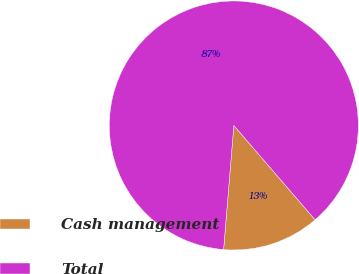Convert chart to OTSL. <chart><loc_0><loc_0><loc_500><loc_500><pie_chart><fcel>Cash management<fcel>Total<nl><fcel>12.63%<fcel>87.37%<nl></chart> 